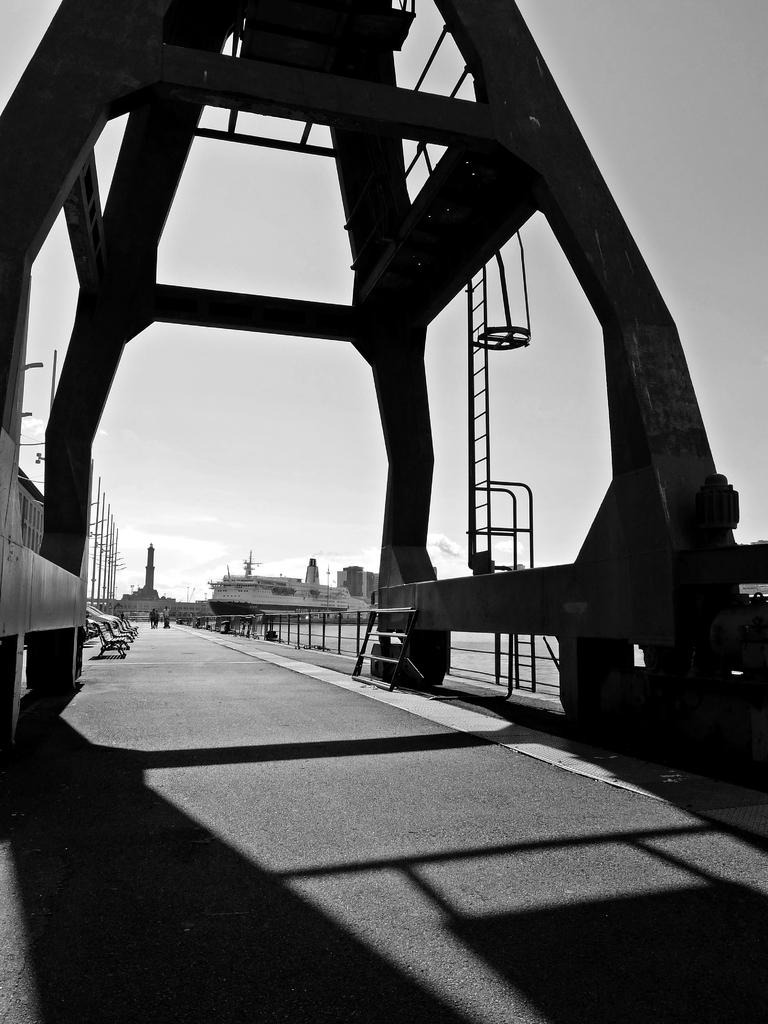What is one of the objects in the image that people might use to reach a higher location? There is a ladder in the image. What is another object in the image that might be used to separate or enclose an area? There is a fence in the image. What type of seating can be seen in the image? There are benches in the image. What can be seen on the ground in the image? There are people on the road in the image. What is visible in the distance in the image? There is a ship visible in the background of the image. What is visible above the ship in the image? The sky is visible in the background of the image. Where is the hill located in the image? There is no hill present in the image. What type of branch is being used by the people on the road in the image? There are no branches visible in the image; people are on the road without any branches. 